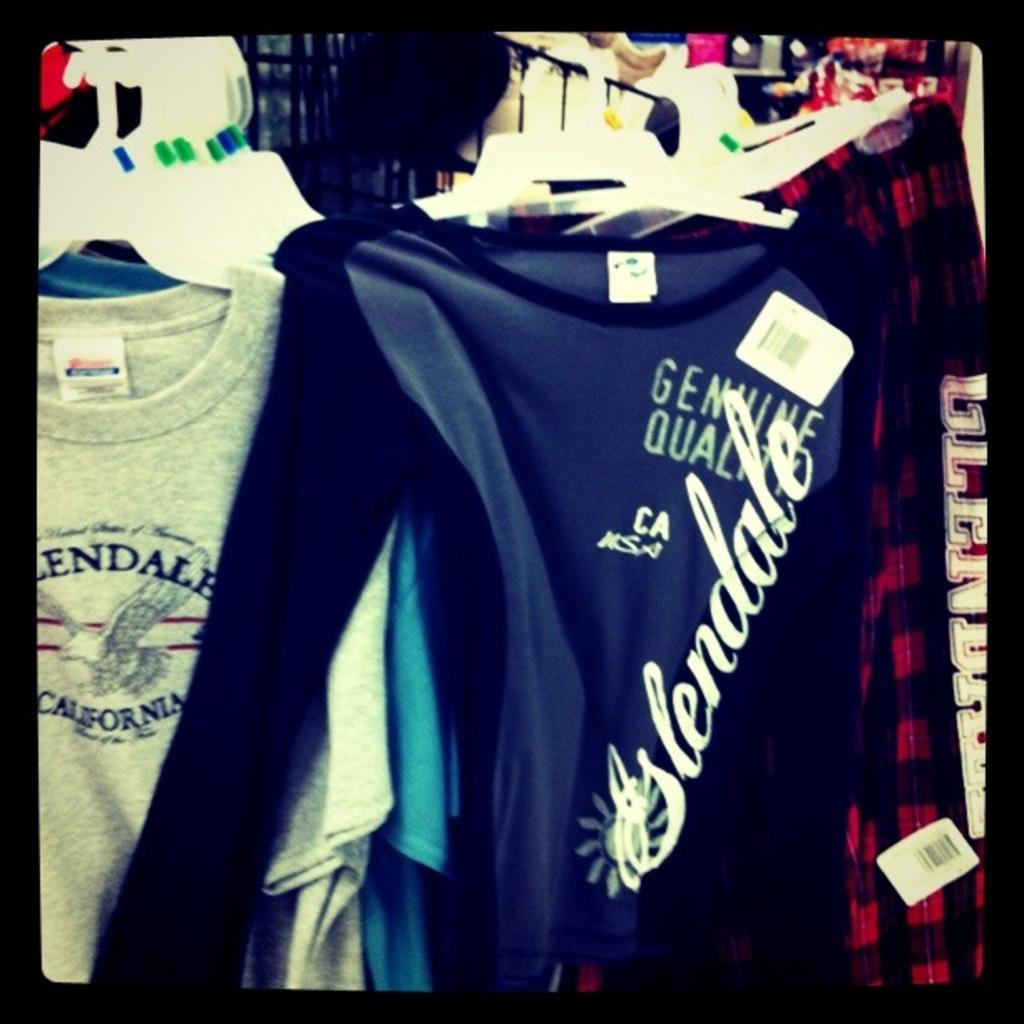What brand in this shirt?
Your answer should be compact. Glendale. What state is abbreviated on the front of the blue shirt?
Provide a short and direct response. California. 